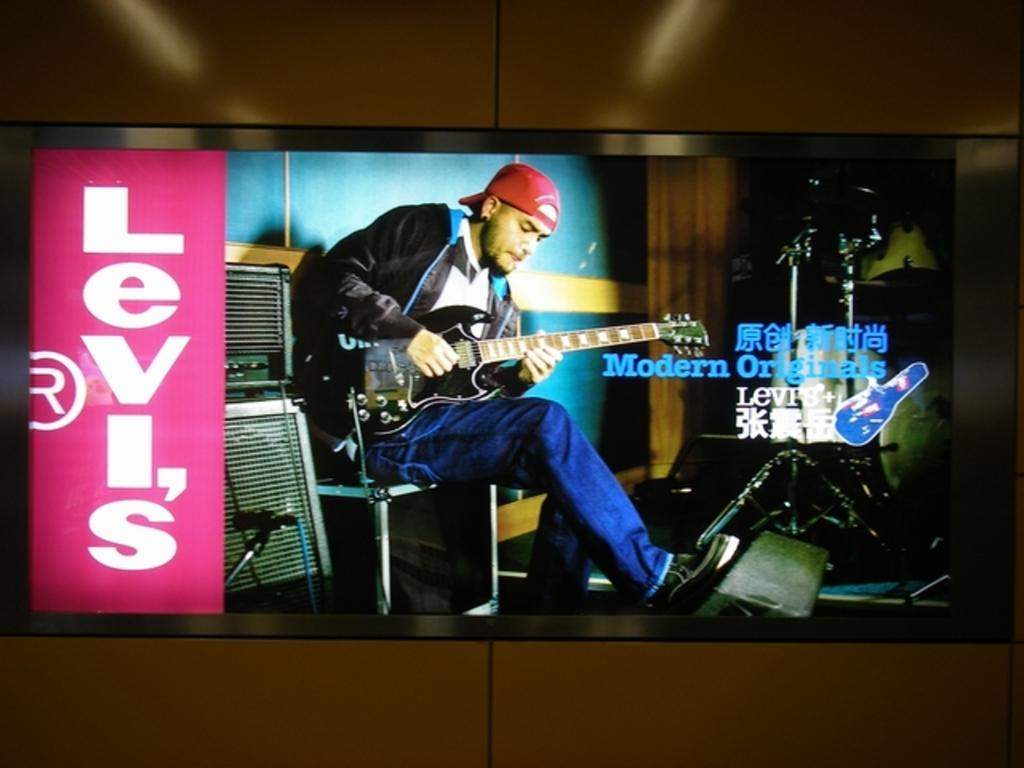Provide a one-sentence caption for the provided image. a sign that has the word Levis on it. 